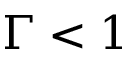Convert formula to latex. <formula><loc_0><loc_0><loc_500><loc_500>\Gamma < 1</formula> 